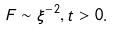Convert formula to latex. <formula><loc_0><loc_0><loc_500><loc_500>F \sim \xi ^ { - 2 } , t > 0 .</formula> 